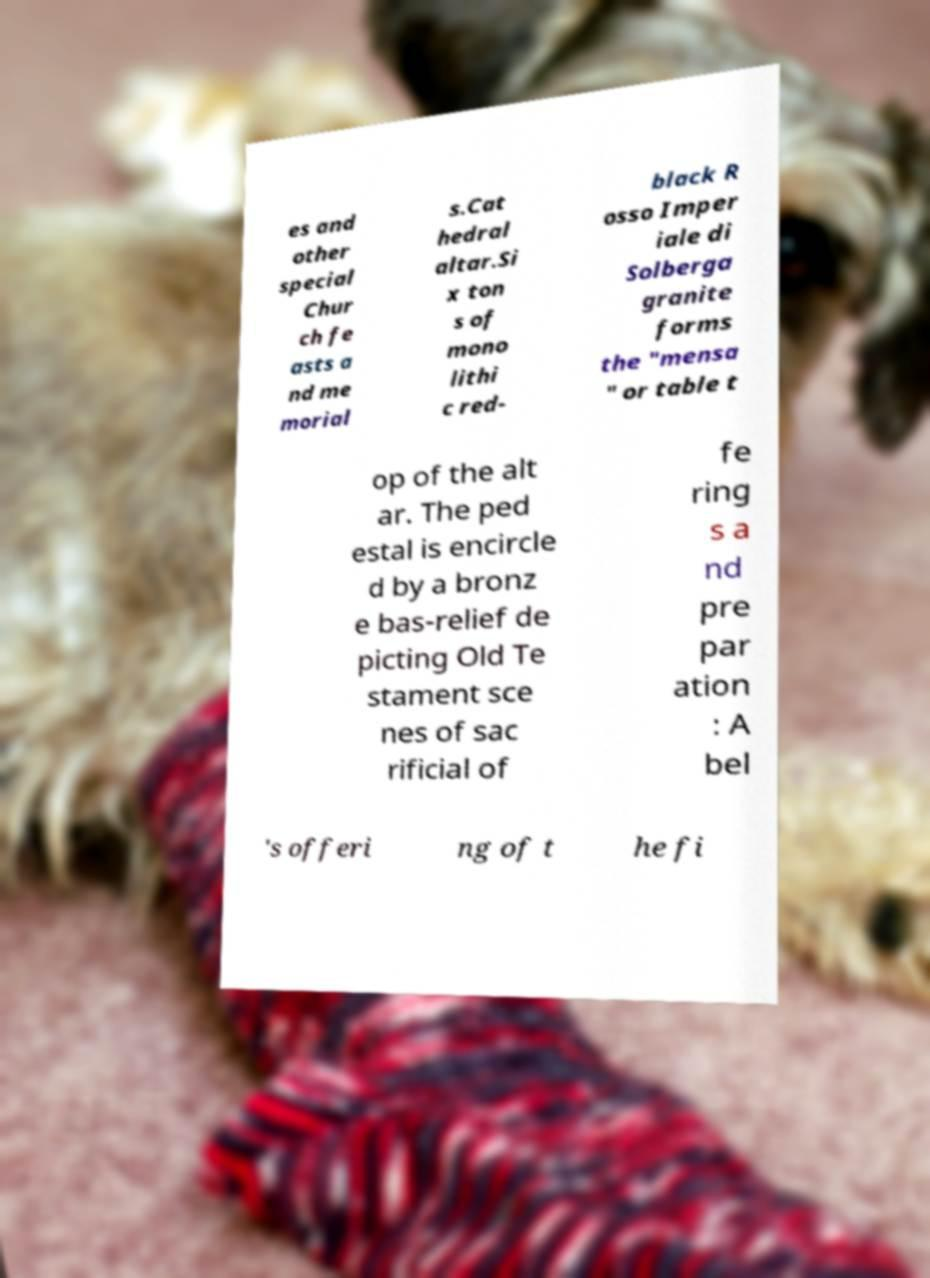For documentation purposes, I need the text within this image transcribed. Could you provide that? es and other special Chur ch fe asts a nd me morial s.Cat hedral altar.Si x ton s of mono lithi c red- black R osso Imper iale di Solberga granite forms the "mensa " or table t op of the alt ar. The ped estal is encircle d by a bronz e bas-relief de picting Old Te stament sce nes of sac rificial of fe ring s a nd pre par ation : A bel 's offeri ng of t he fi 